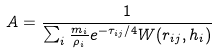Convert formula to latex. <formula><loc_0><loc_0><loc_500><loc_500>A = \frac { 1 } { \sum _ { i } \frac { m _ { i } } { \rho _ { i } } e ^ { - \tau _ { i j } / 4 } W ( { r } _ { i j } , h _ { i } ) }</formula> 